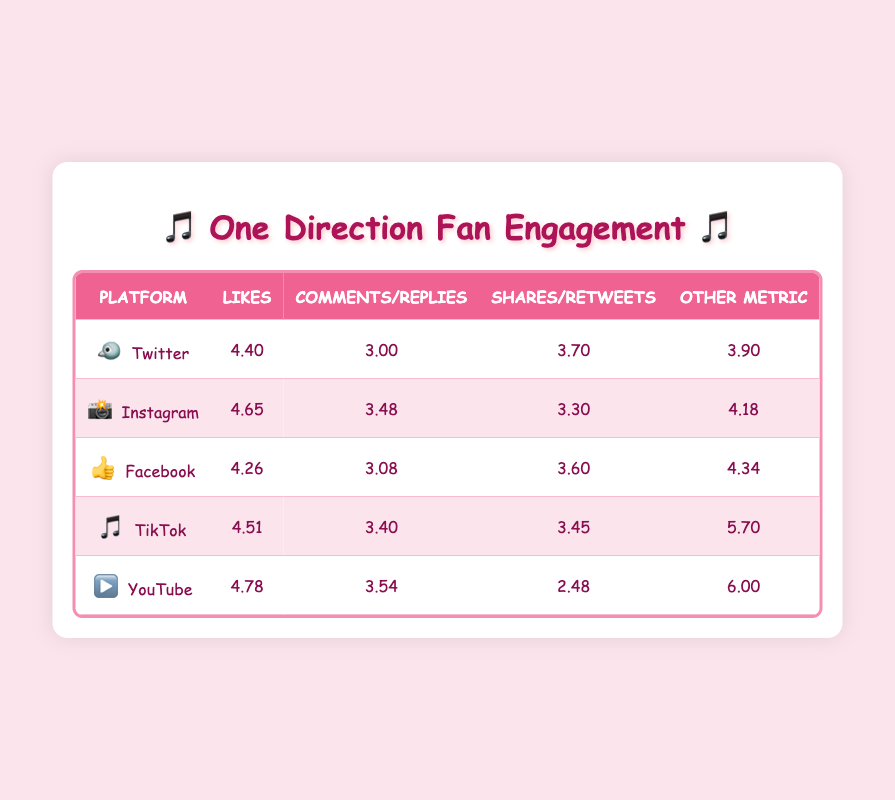What is the platform with the highest number of likes? Looking at the table, YouTube has the highest number of likes with 60000, compared to 45000 on Instagram, 32000 on TikTok, 25000 on Twitter, and 18000 on Facebook.
Answer: YouTube What is the average number of comments across all platforms? To find the average, sum the comments: 1000 (Twitter) + 3000 (Instagram) + 1200 (Facebook) + 2500 (TikTok) + 3500 (YouTube) = 11000. Then divide by the number of platforms, which is 5. So, 11000 / 5 = 2200.
Answer: 2200 Is TikTok's number of shares greater than Instagram's? TikTok has 2800 shares while Instagram has 2000 shares, so yes, TikTok's shares are greater.
Answer: Yes Which platform has the lowest post reach and what is the value? The lowest post reach is on Facebook, which has a post reach of 22000.
Answer: Facebook, 22000 If we compare the likes on Twitter and Facebook, which one is higher? On the table, Twitter has 25000 likes while Facebook has 18000 likes, making Twitter's likes higher.
Answer: Twitter What is the total number of shares from Twitter and Facebook combined? For the total, add Twitter's shares (5000) and Facebook's shares (4000) together. 5000 + 4000 = 9000, so the total shares is 9000.
Answer: 9000 Does YouTube have more dislikes than TikTok has comments? YouTube has 300 dislikes while TikTok has 2500 comments, meaning that YouTube does not have more dislikes than TikTok has comments.
Answer: No Which platform has the highest value for another metric and what is it? The highest value for another metric is TikTok's views, which stand at 500000, compared to the other platforms.
Answer: TikTok, 500000 What is the difference in likes between Instagram and TikTok? Instagram has 45000 likes while TikTok has 32000. The difference is 45000 - 32000 = 13000.
Answer: 13000 